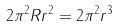<formula> <loc_0><loc_0><loc_500><loc_500>2 \pi ^ { 2 } R r ^ { 2 } = 2 \pi ^ { 2 } r ^ { 3 }</formula> 